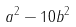<formula> <loc_0><loc_0><loc_500><loc_500>a ^ { 2 } - 1 0 b ^ { 2 }</formula> 